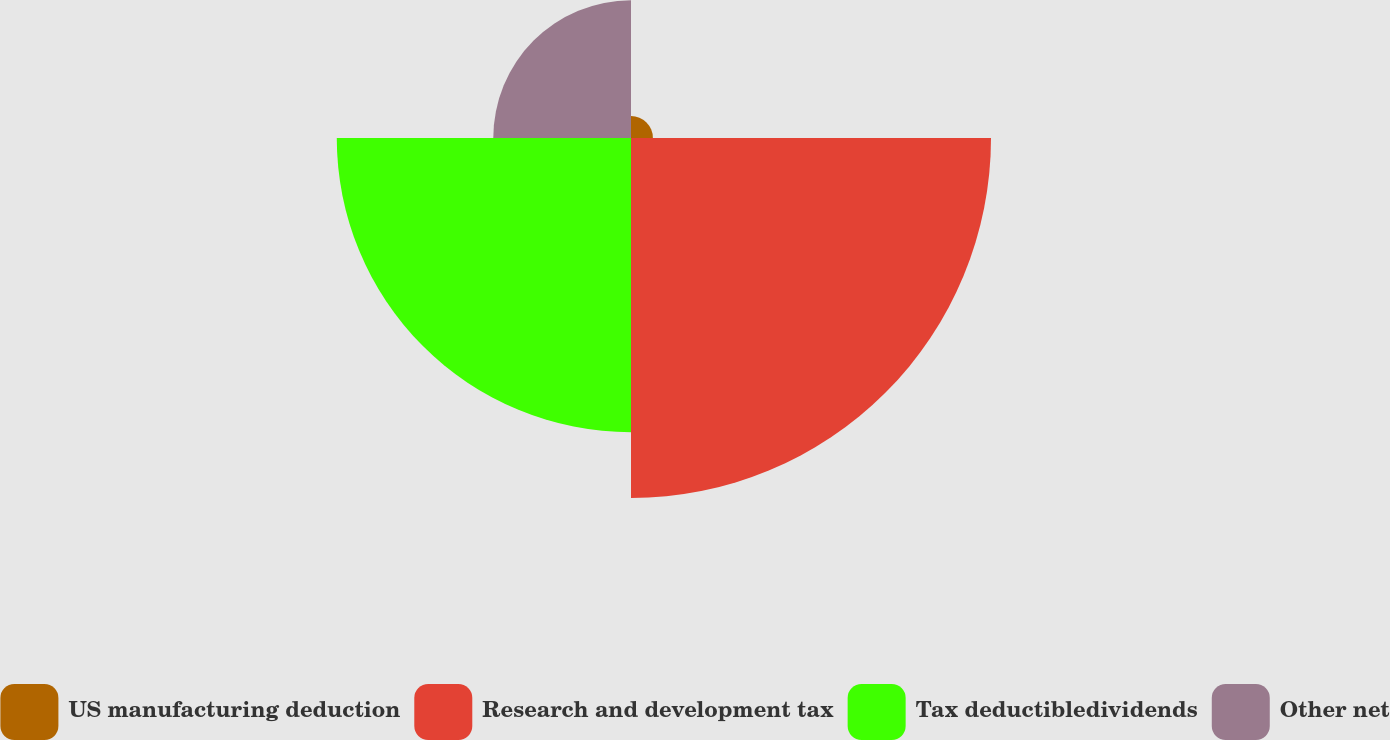<chart> <loc_0><loc_0><loc_500><loc_500><pie_chart><fcel>US manufacturing deduction<fcel>Research and development tax<fcel>Tax deductibledividends<fcel>Other net<nl><fcel>2.69%<fcel>44.23%<fcel>36.15%<fcel>16.92%<nl></chart> 